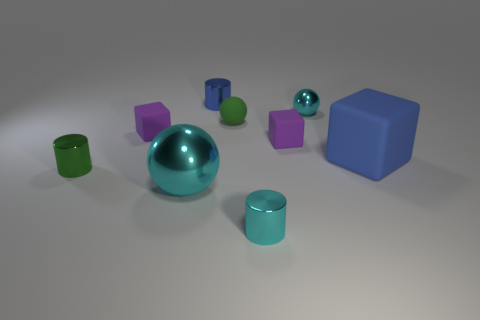Subtract all brown blocks. Subtract all gray cylinders. How many blocks are left? 3 Add 1 large matte blocks. How many objects exist? 10 Subtract all balls. How many objects are left? 6 Add 2 large blue rubber blocks. How many large blue rubber blocks are left? 3 Add 3 small blue objects. How many small blue objects exist? 4 Subtract 0 gray cylinders. How many objects are left? 9 Subtract all cyan cylinders. Subtract all large shiny objects. How many objects are left? 7 